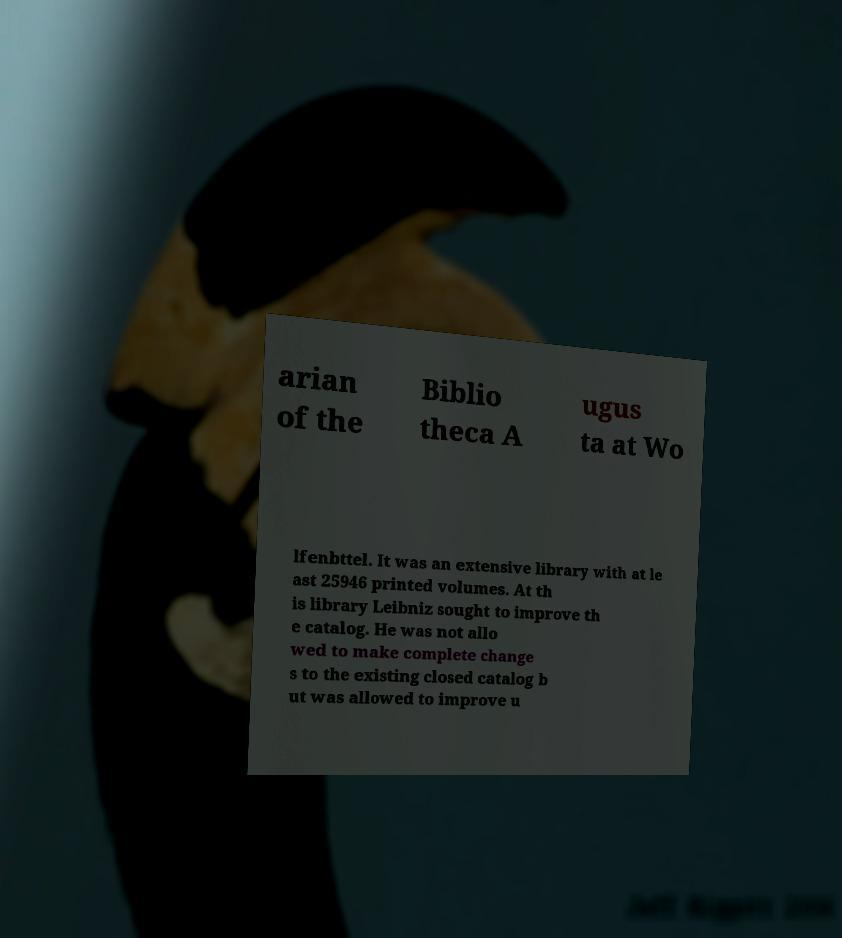Please read and relay the text visible in this image. What does it say? arian of the Biblio theca A ugus ta at Wo lfenbttel. It was an extensive library with at le ast 25946 printed volumes. At th is library Leibniz sought to improve th e catalog. He was not allo wed to make complete change s to the existing closed catalog b ut was allowed to improve u 